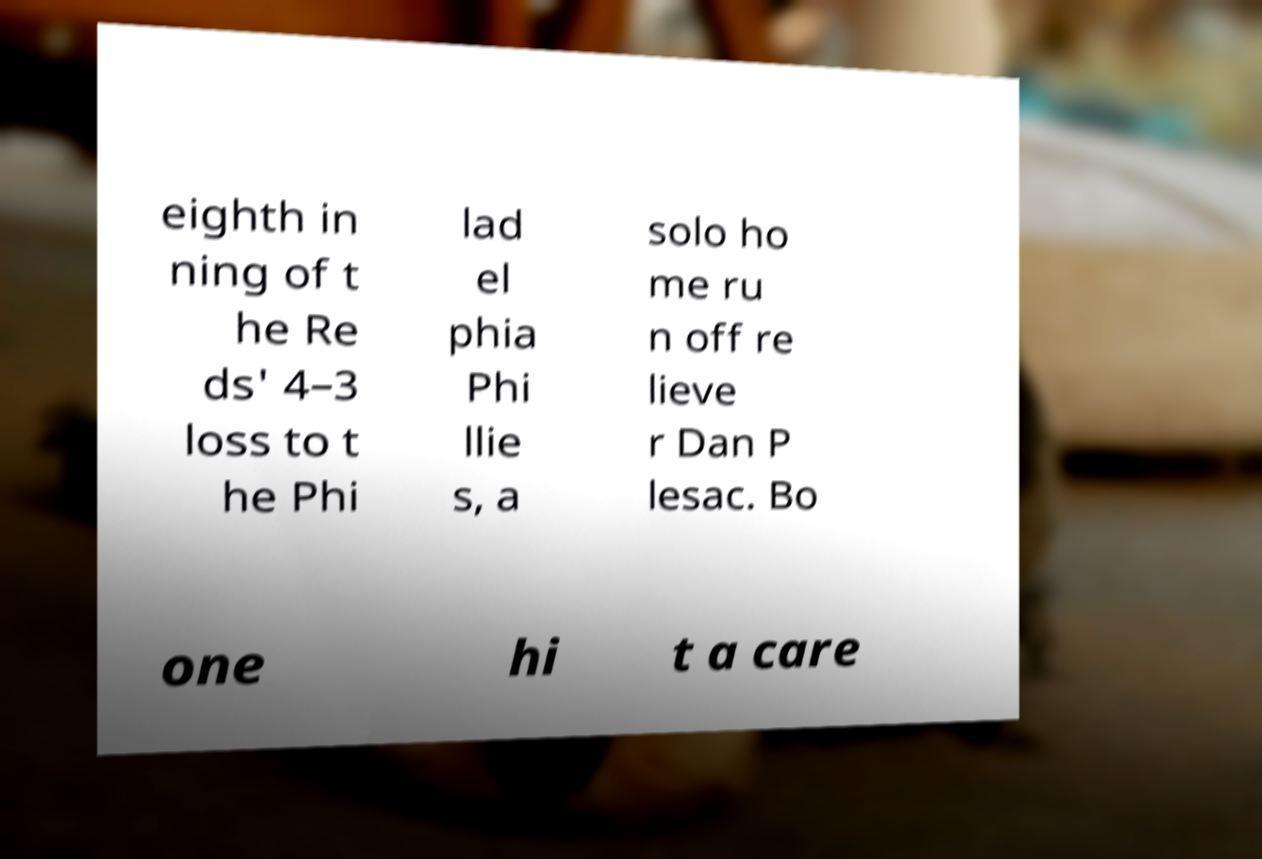I need the written content from this picture converted into text. Can you do that? eighth in ning of t he Re ds' 4–3 loss to t he Phi lad el phia Phi llie s, a solo ho me ru n off re lieve r Dan P lesac. Bo one hi t a care 